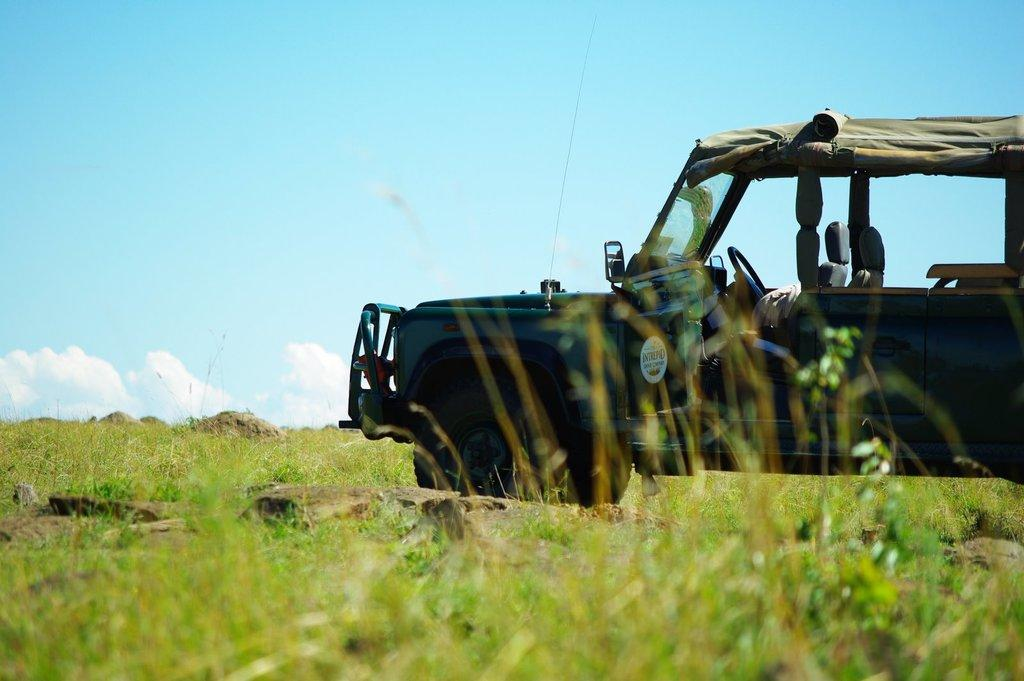What is the main subject of the image? There is a vehicle in the image. Where is the vehicle located? The vehicle is on the grass. What other elements can be seen in the image? Rocks are present in the image. What is visible natural element is in the background of the image? The sky is visible in the background of the image. What can be observed in the sky? Clouds are present in the sky. How does the beginner learn to use the hydrant in the image? There is no hydrant present in the image, so it is not possible to answer a question about learning to use one. 